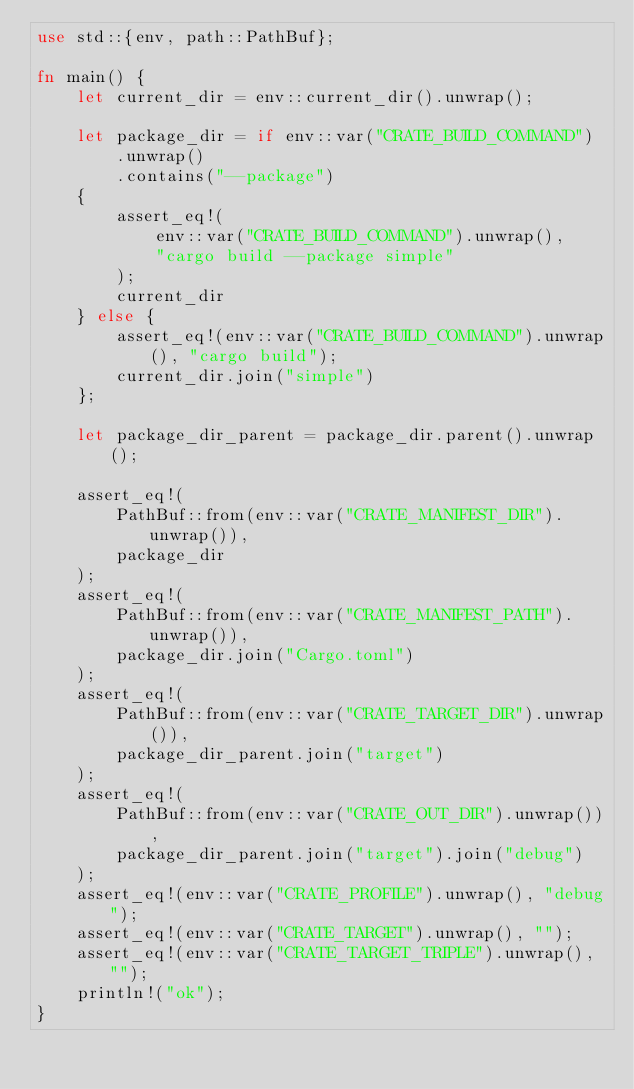<code> <loc_0><loc_0><loc_500><loc_500><_Rust_>use std::{env, path::PathBuf};

fn main() {
    let current_dir = env::current_dir().unwrap();

    let package_dir = if env::var("CRATE_BUILD_COMMAND")
        .unwrap()
        .contains("--package")
    {
        assert_eq!(
            env::var("CRATE_BUILD_COMMAND").unwrap(),
            "cargo build --package simple"
        );
        current_dir
    } else {
        assert_eq!(env::var("CRATE_BUILD_COMMAND").unwrap(), "cargo build");
        current_dir.join("simple")
    };

    let package_dir_parent = package_dir.parent().unwrap();

    assert_eq!(
        PathBuf::from(env::var("CRATE_MANIFEST_DIR").unwrap()),
        package_dir
    );
    assert_eq!(
        PathBuf::from(env::var("CRATE_MANIFEST_PATH").unwrap()),
        package_dir.join("Cargo.toml")
    );
    assert_eq!(
        PathBuf::from(env::var("CRATE_TARGET_DIR").unwrap()),
        package_dir_parent.join("target")
    );
    assert_eq!(
        PathBuf::from(env::var("CRATE_OUT_DIR").unwrap()),
        package_dir_parent.join("target").join("debug")
    );
    assert_eq!(env::var("CRATE_PROFILE").unwrap(), "debug");
    assert_eq!(env::var("CRATE_TARGET").unwrap(), "");
    assert_eq!(env::var("CRATE_TARGET_TRIPLE").unwrap(), "");
    println!("ok");
}
</code> 